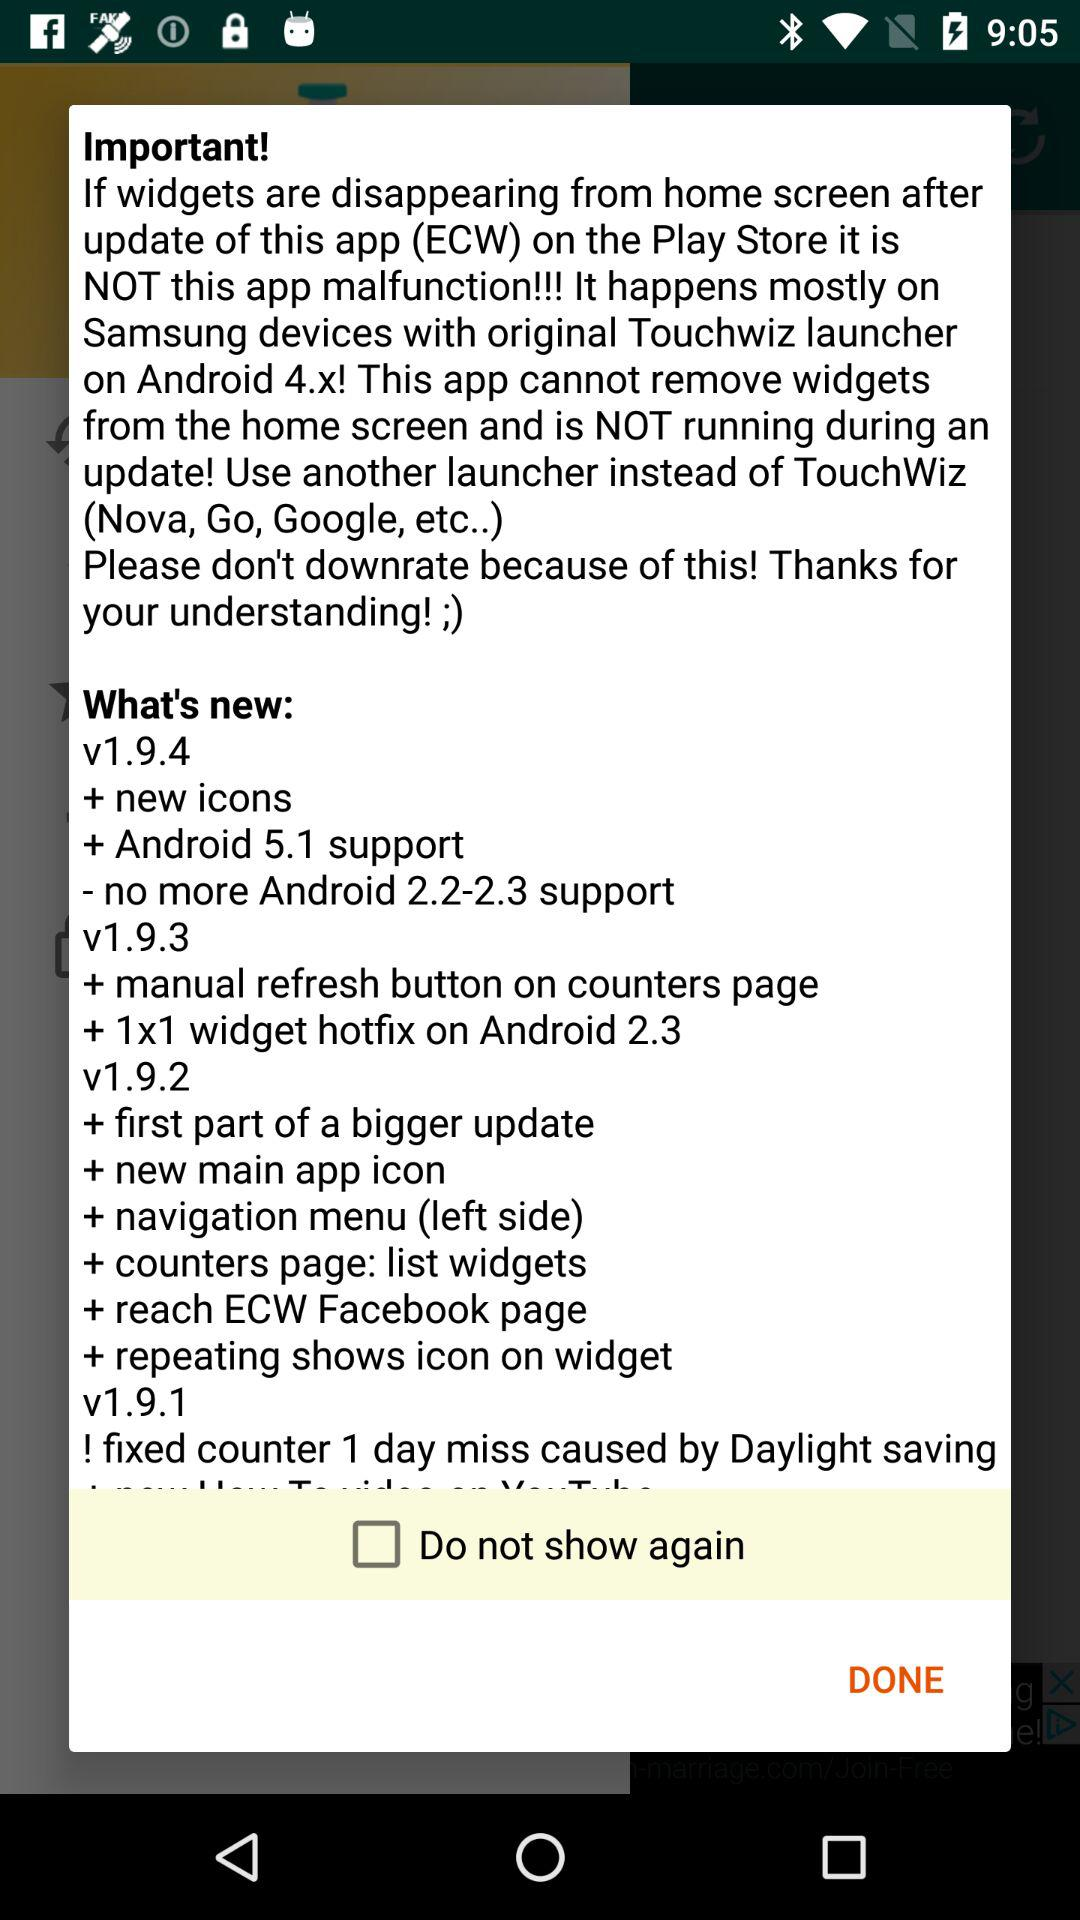When was version 1.9.4 updated?
When the provided information is insufficient, respond with <no answer>. <no answer> 